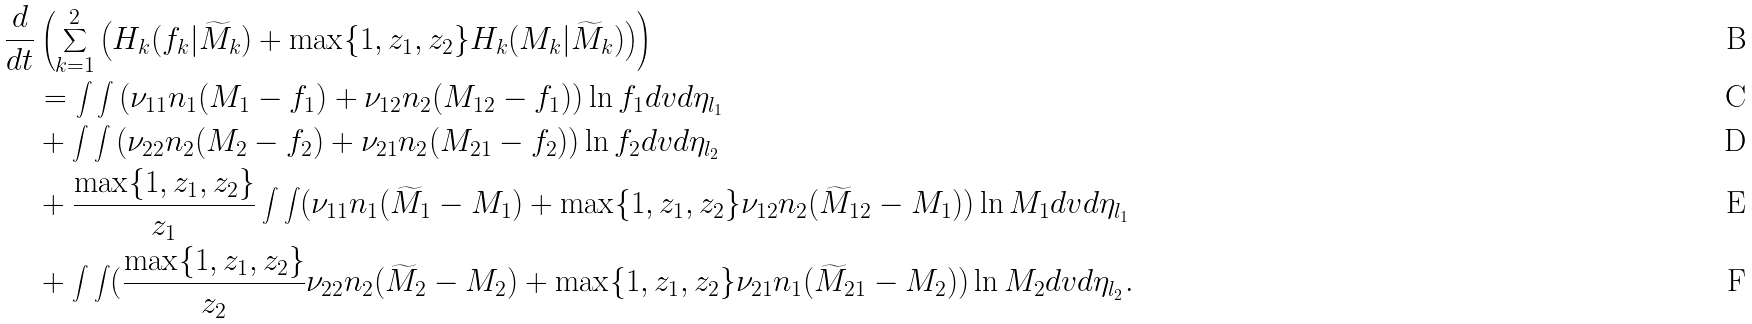Convert formula to latex. <formula><loc_0><loc_0><loc_500><loc_500>\frac { d } { d t } & \left ( \sum _ { k = 1 } ^ { 2 } \left ( H _ { k } ( f _ { k } | \widetilde { M } _ { k } ) + \max \{ 1 , z _ { 1 } , z _ { 2 } \} H _ { k } ( M _ { k } | \widetilde { M } _ { k } ) \right ) \right ) \\ & = \int \int \left ( \nu _ { 1 1 } n _ { 1 } ( M _ { 1 } - f _ { 1 } ) + \nu _ { 1 2 } n _ { 2 } ( M _ { 1 2 } - f _ { 1 } ) \right ) \ln f _ { 1 } d v d \eta _ { l _ { 1 } } \\ & + \int \int \left ( \nu _ { 2 2 } n _ { 2 } ( M _ { 2 } - f _ { 2 } ) + \nu _ { 2 1 } n _ { 2 } ( M _ { 2 1 } - f _ { 2 } ) \right ) \ln f _ { 2 } d v d \eta _ { l _ { 2 } } \\ & + \frac { \max \{ 1 , z _ { 1 } , z _ { 2 } \} } { z _ { 1 } } \int \int ( \nu _ { 1 1 } n _ { 1 } ( \widetilde { M } _ { 1 } - M _ { 1 } ) + \max \{ 1 , z _ { 1 } , z _ { 2 } \} \nu _ { 1 2 } n _ { 2 } ( \widetilde { M } _ { 1 2 } - M _ { 1 } ) ) \ln M _ { 1 } d v d \eta _ { l _ { 1 } } \\ & + \int \int ( \frac { \max \{ 1 , z _ { 1 } , z _ { 2 } \} } { z _ { 2 } } \nu _ { 2 2 } n _ { 2 } ( \widetilde { M } _ { 2 } - M _ { 2 } ) + \max \{ 1 , z _ { 1 } , z _ { 2 } \} \nu _ { 2 1 } n _ { 1 } ( \widetilde { M } _ { 2 1 } - M _ { 2 } ) ) \ln M _ { 2 } d v d \eta _ { l _ { 2 } } .</formula> 